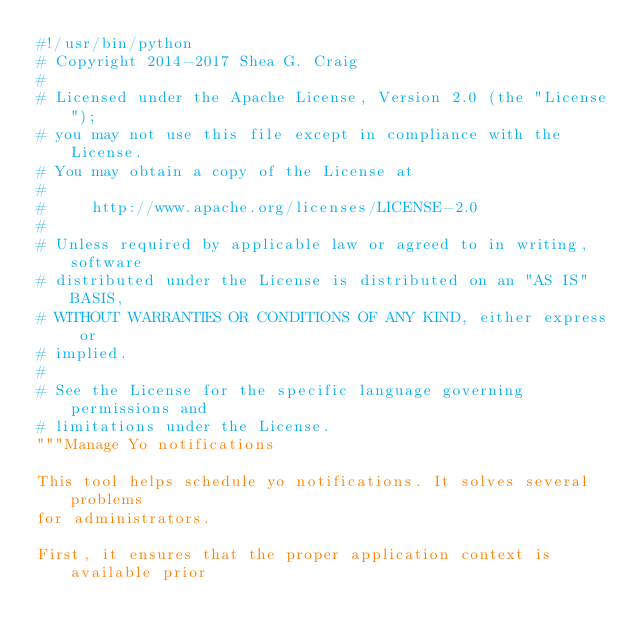Convert code to text. <code><loc_0><loc_0><loc_500><loc_500><_Python_>#!/usr/bin/python
# Copyright 2014-2017 Shea G. Craig
#
# Licensed under the Apache License, Version 2.0 (the "License");
# you may not use this file except in compliance with the License.
# You may obtain a copy of the License at
#
#     http://www.apache.org/licenses/LICENSE-2.0
#
# Unless required by applicable law or agreed to in writing, software
# distributed under the License is distributed on an "AS IS" BASIS,
# WITHOUT WARRANTIES OR CONDITIONS OF ANY KIND, either express or
# implied.
#
# See the License for the specific language governing permissions and
# limitations under the License.
"""Manage Yo notifications

This tool helps schedule yo notifications. It solves several problems
for administrators.

First, it ensures that the proper application context is available prior</code> 